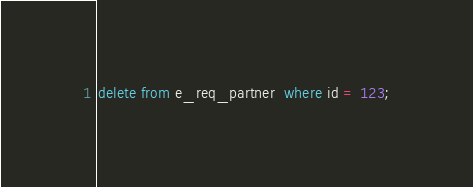Convert code to text. <code><loc_0><loc_0><loc_500><loc_500><_SQL_>delete from e_req_partner  where id = 123;</code> 